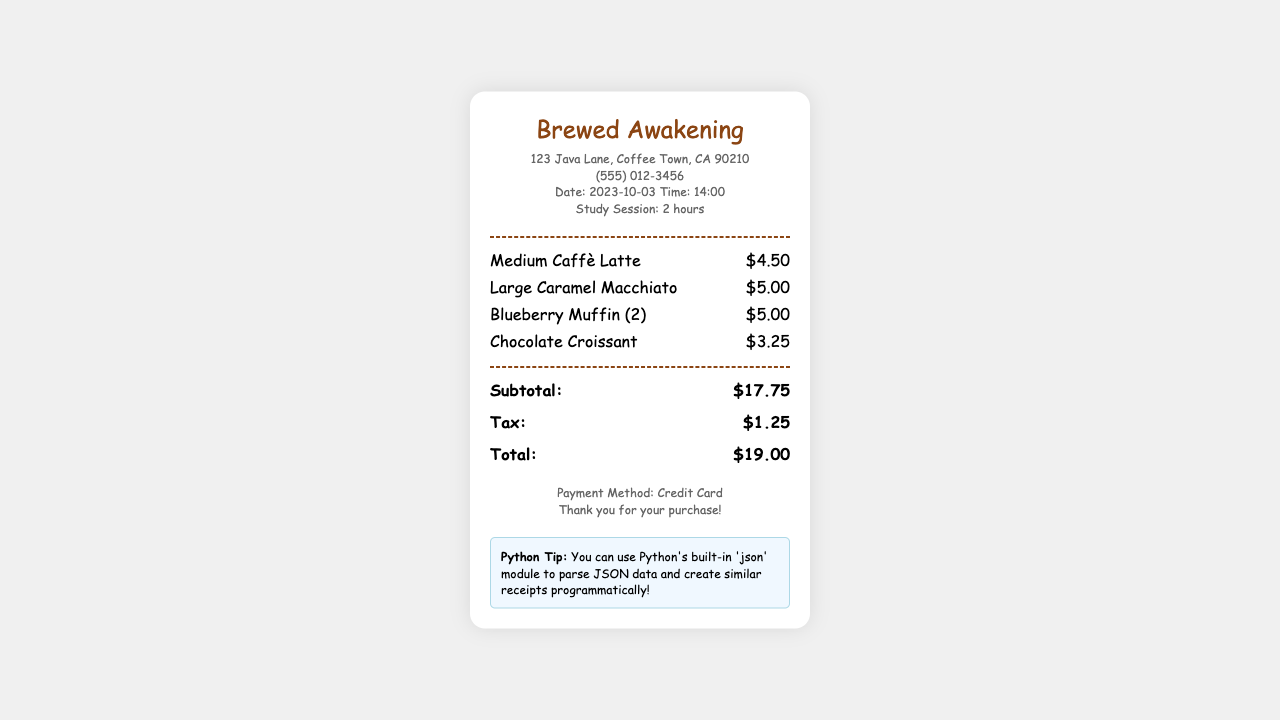What is the name of the coffee shop? The name of the coffee shop is prominently displayed at the top of the receipt.
Answer: Brewed Awakening What is the date of the receipt? The receipt shows the date in the header section.
Answer: 2023-10-03 What was the total amount spent? The total amount is calculated as shown in the total section of the receipt.
Answer: $19.00 How much was the tax? The tax amount is listed separately on the receipt for clarity.
Answer: $1.25 What items were ordered? The items are listed under the items section, detailing each ordered beverage and pastry.
Answer: Medium Caffè Latte, Large Caramel Macchiato, Blueberry Muffin (2), Chocolate Croissant How much did the Blueberry Muffin cost? The cost of the Blueberry Muffin is shown next to the item in the receipt.
Answer: $5.00 What payment method was used? The payment method is specified in the footer of the receipt.
Answer: Credit Card How many hours did the study session last? The duration of the study session is mentioned in the info section of the receipt.
Answer: 2 hours What is the phone number of the coffee shop? The coffee shop's contact number is provided in the info section.
Answer: (555) 012-3456 